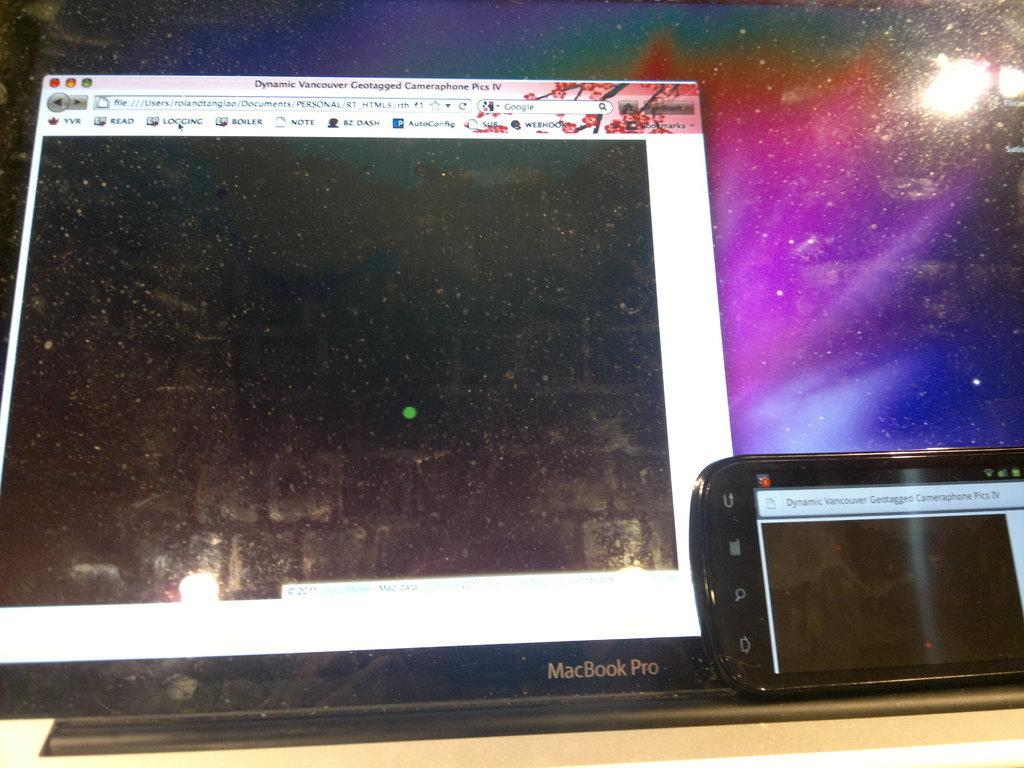<image>
Present a compact description of the photo's key features. A phone in front of a mac book pro screen that says Dynamic Vancouver Geotagged Pics IV. 